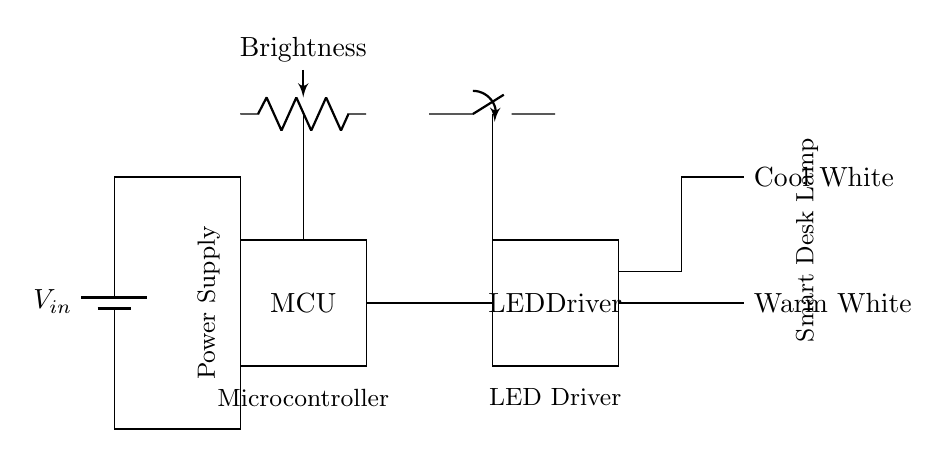What is the main function of the microcontroller in this circuit? The microcontroller processes inputs from the brightness control potentiometer and color temperature switch to adjust the output to the LED driver, thereby controlling the lamp's brightness and color temperature.
Answer: Control What type of switches are used for the color temperature adjustment? The circuit employs a single pole, double throw (SPDT) switch for selecting between different color temperature options.
Answer: SPST What are the two colors of LEDs in the smart desk lamp? The circuit includes two types of LEDs: warm white and cool white. These are used to provide adjustable color temperatures for the lamp.
Answer: Yellow and blue How does the brightness control mechanism operate? The brightness control is implemented through a potentiometer that adjusts the resistance, which alters the voltage supplied to the LED driver, changing the intensity of light emitted by the LEDs.
Answer: Potentiometer What is the power source for this smart desk lamp circuit? The power supply for this circuit is provided by a battery, which delivers the necessary voltage to operate the microcontroller and LEDs.
Answer: Battery What component is responsible for controlling the LED output? The LED driver is the component that regulates the current and voltage supplied to the LEDs based on signals from the microcontroller.
Answer: LED Driver 